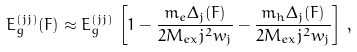Convert formula to latex. <formula><loc_0><loc_0><loc_500><loc_500>E ^ { ( j j ) } _ { g } ( F ) \approx E ^ { ( j j ) } _ { g } \, \left [ 1 - \frac { m _ { e } \Delta _ { j } ( F ) } { 2 M _ { e x } j ^ { 2 } w _ { j } } - \frac { m _ { h } \Delta _ { j } ( F ) } { 2 M _ { e x } j ^ { 2 } w _ { j } } \right ] \, ,</formula> 